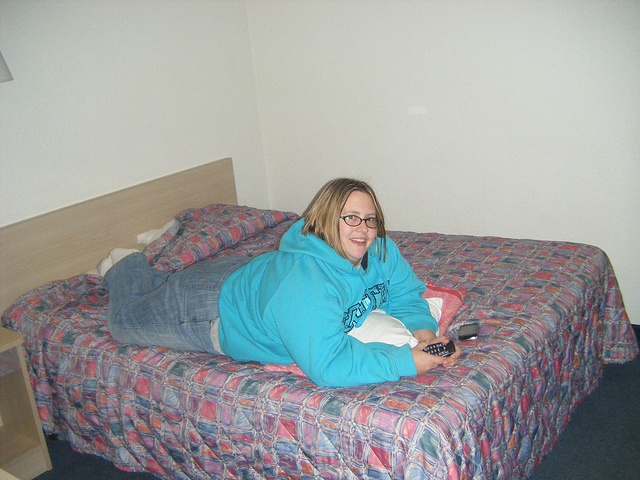Describe the objects in this image and their specific colors. I can see bed in darkgray and gray tones, people in darkgray, gray, and lightblue tones, remote in darkgray, black, and gray tones, and cell phone in darkgray, gray, and black tones in this image. 